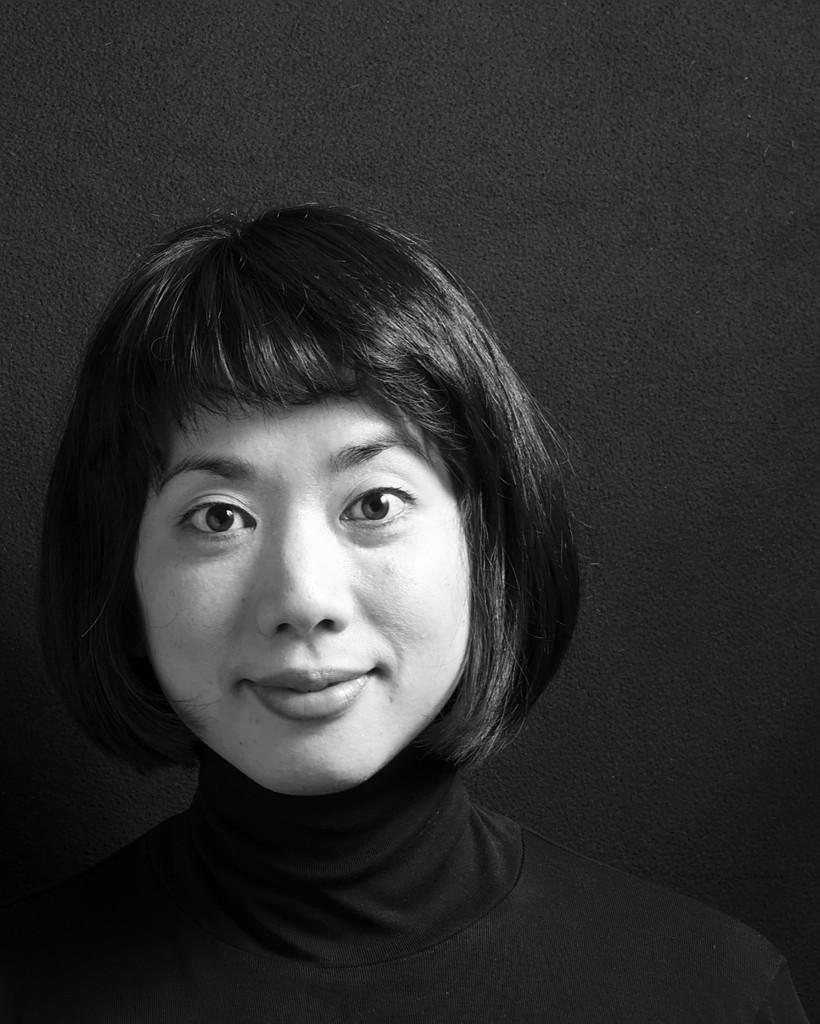What is the main subject of the image? The main subject of the image is a woman. What can be said about the color scheme of the image? The image is black and white in color. How many elbows does the woman have in the image? The number of elbows cannot be determined from the image, as it is in black and white and does not provide enough detail to count elbows. What type of support is the woman using in the image? There is no visible support for the woman in the image. 